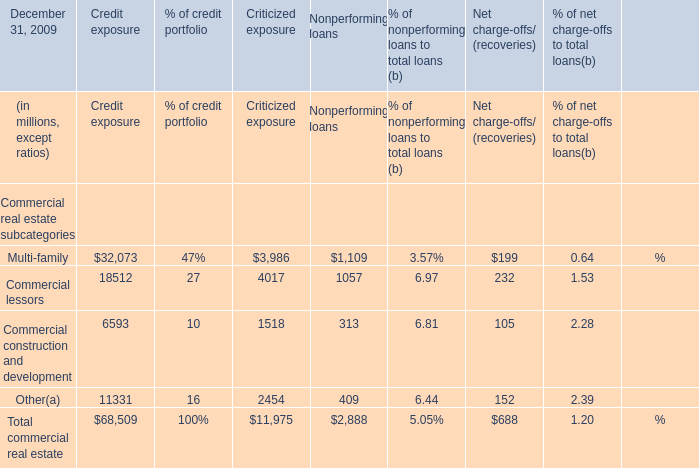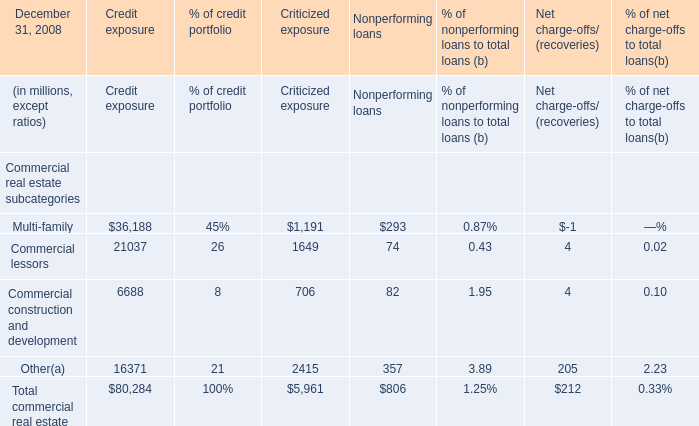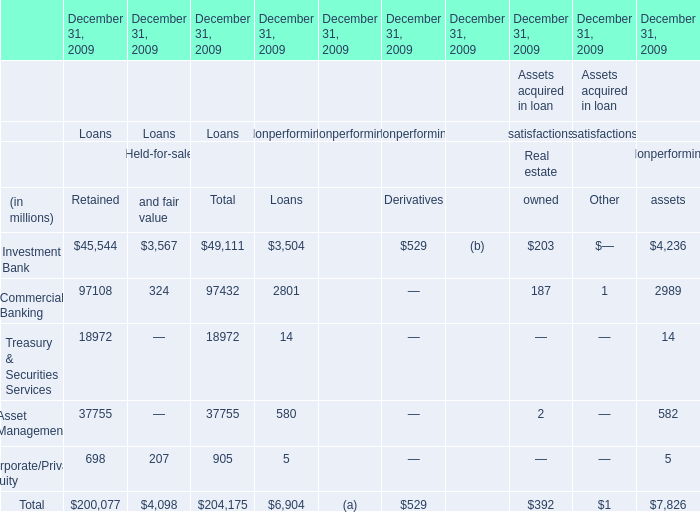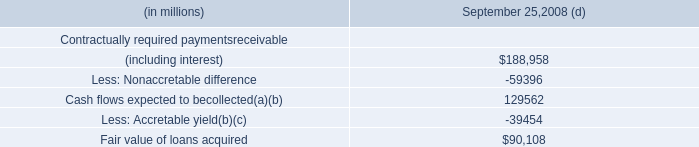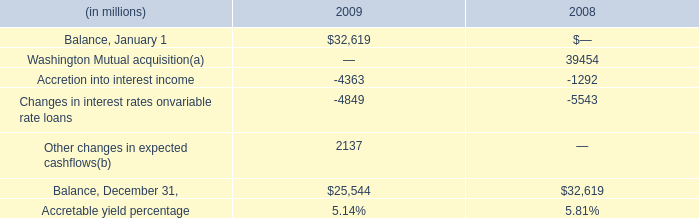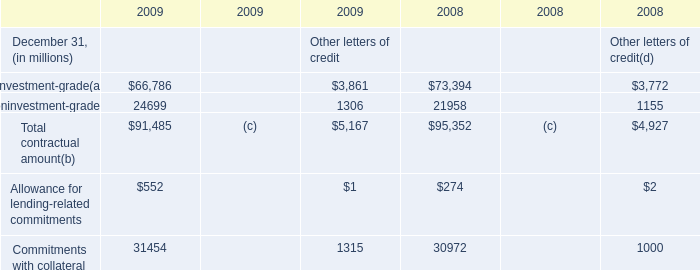What is the sum of Commercial lessors in the range of100 and 30000 in 2008? (in million) 
Computations: (((21037 + 1649) + 74) + 4)
Answer: 22764.0. 